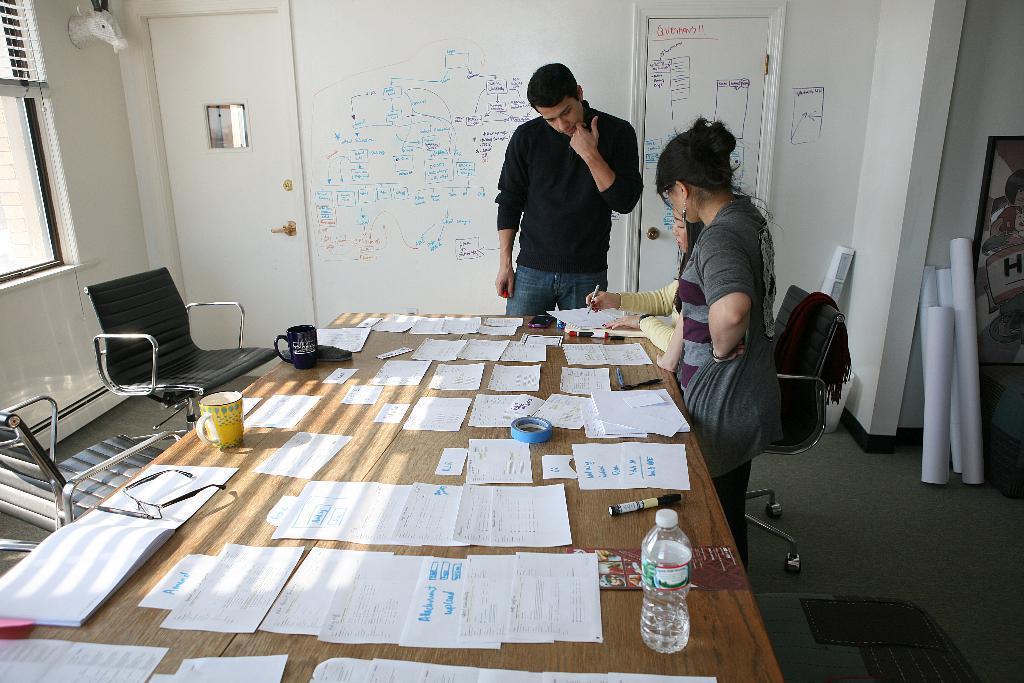Please provide a concise description of this image. In this image i can see a woman sitting on a chair and other persons standing beside her, I can see a table and number of papers on it, a water bottle, a cup and a pen on it. I can also see some chairs behind the table. In the back ground i can see a white board, a door and few charts. 